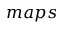Convert formula to latex. <formula><loc_0><loc_0><loc_500><loc_500>m a p s</formula> 